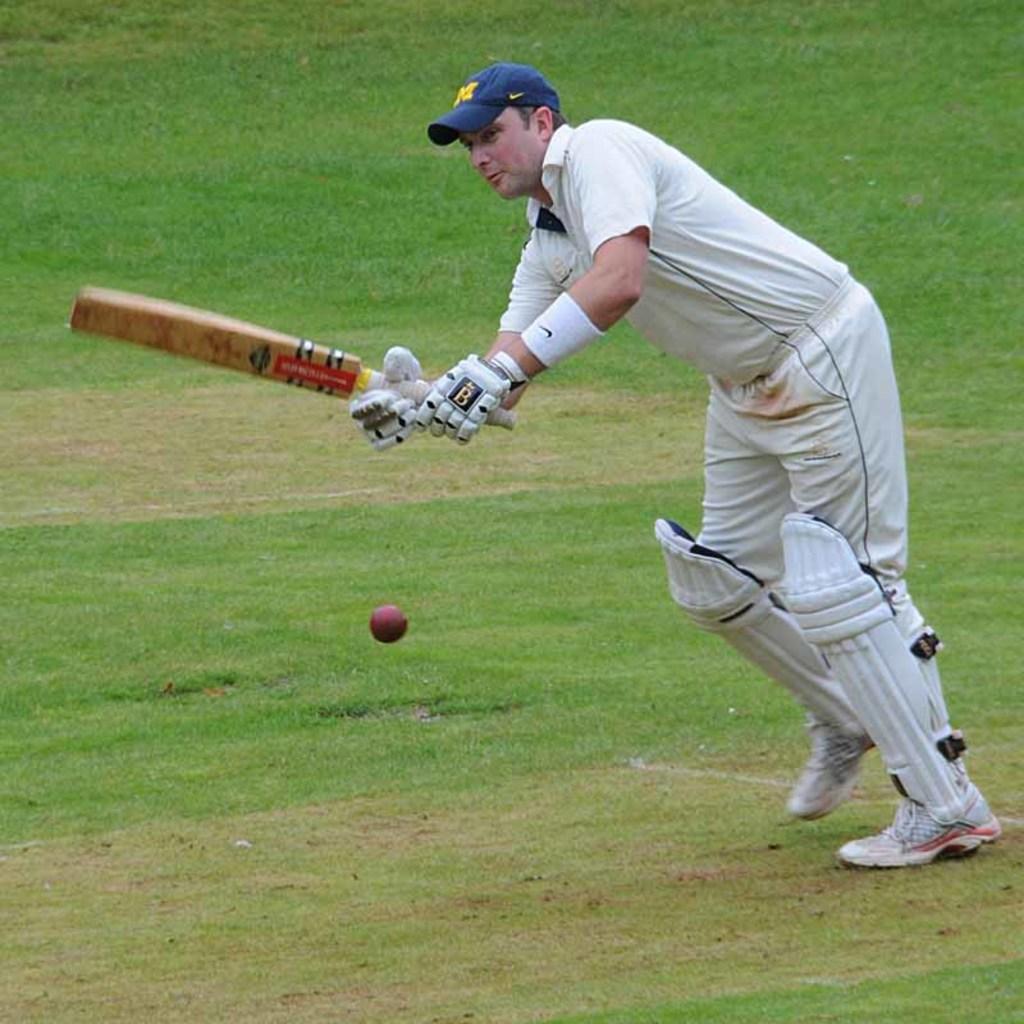Describe this image in one or two sentences. In this image I can see a person playing cricket in a ground. He is wearing a blue cap and white dress. 